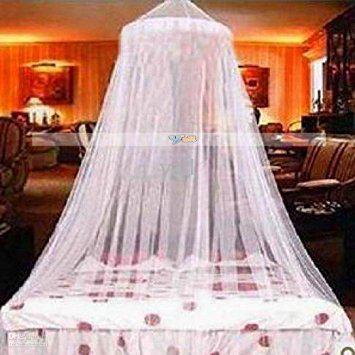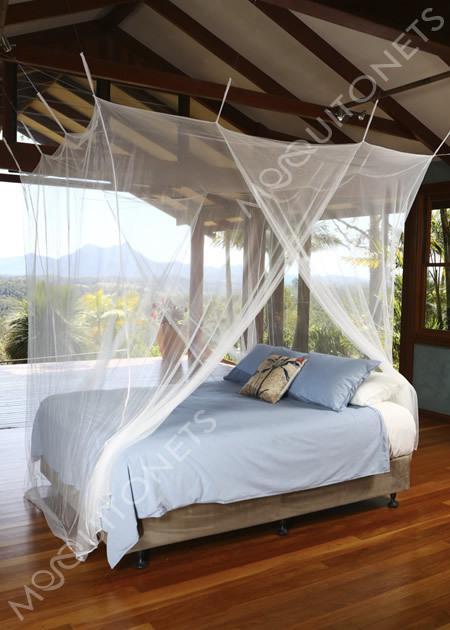The first image is the image on the left, the second image is the image on the right. For the images displayed, is the sentence "One image shows a canopy suspended from the ceiling that drapes the bed from a cone shape." factually correct? Answer yes or no. Yes. 